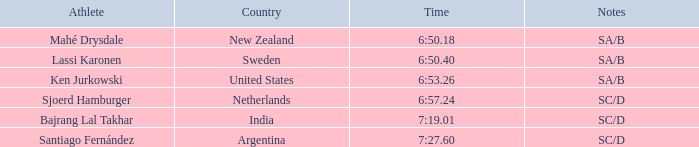What is the aggregate of the positions for india? 5.0. 